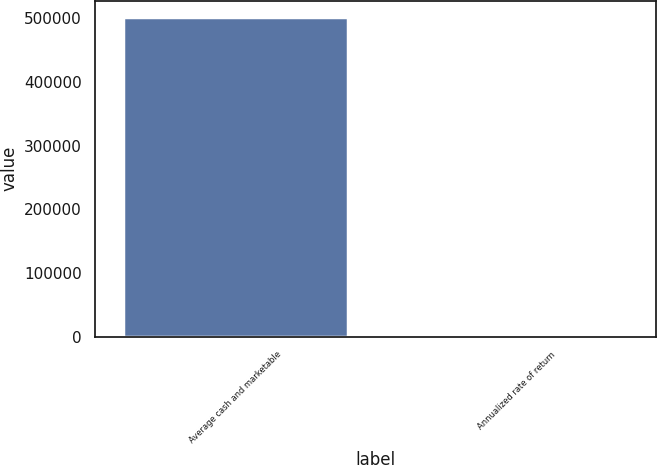Convert chart. <chart><loc_0><loc_0><loc_500><loc_500><bar_chart><fcel>Average cash and marketable<fcel>Annualized rate of return<nl><fcel>502921<fcel>2.1<nl></chart> 